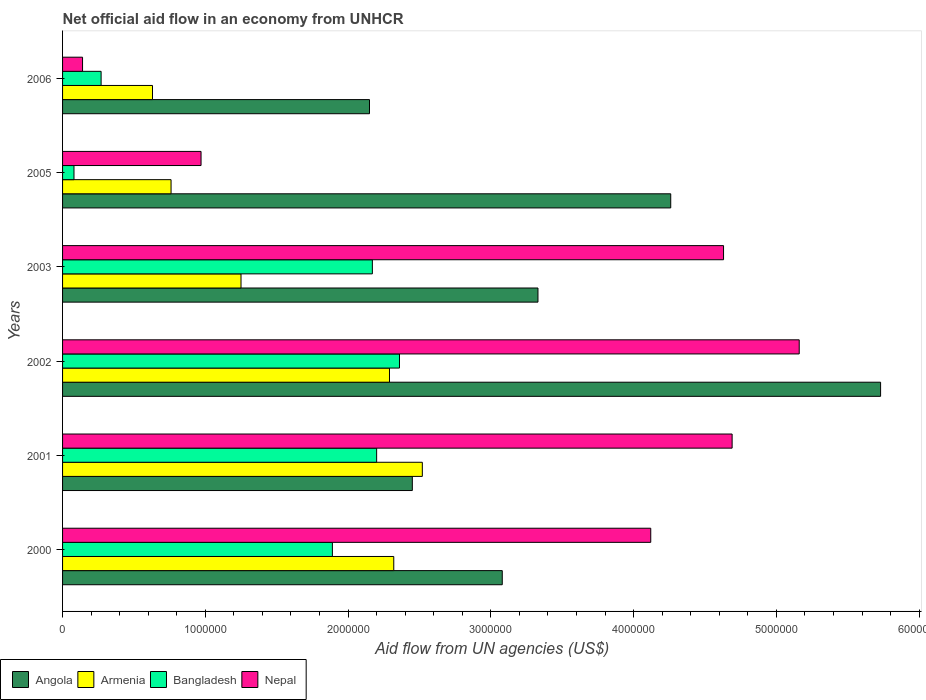How many groups of bars are there?
Give a very brief answer. 6. Are the number of bars per tick equal to the number of legend labels?
Ensure brevity in your answer.  Yes. Are the number of bars on each tick of the Y-axis equal?
Your answer should be very brief. Yes. How many bars are there on the 3rd tick from the top?
Provide a succinct answer. 4. What is the label of the 3rd group of bars from the top?
Your answer should be compact. 2003. What is the net official aid flow in Angola in 2003?
Offer a terse response. 3.33e+06. Across all years, what is the maximum net official aid flow in Nepal?
Your answer should be very brief. 5.16e+06. Across all years, what is the minimum net official aid flow in Nepal?
Your answer should be very brief. 1.40e+05. In which year was the net official aid flow in Bangladesh maximum?
Offer a terse response. 2002. In which year was the net official aid flow in Angola minimum?
Your answer should be compact. 2006. What is the total net official aid flow in Nepal in the graph?
Provide a succinct answer. 1.97e+07. What is the difference between the net official aid flow in Armenia in 2000 and the net official aid flow in Angola in 2002?
Provide a short and direct response. -3.41e+06. What is the average net official aid flow in Armenia per year?
Offer a very short reply. 1.63e+06. In the year 2003, what is the difference between the net official aid flow in Armenia and net official aid flow in Angola?
Provide a succinct answer. -2.08e+06. What is the ratio of the net official aid flow in Armenia in 2000 to that in 2001?
Ensure brevity in your answer.  0.92. Is the net official aid flow in Angola in 2000 less than that in 2006?
Offer a very short reply. No. What is the difference between the highest and the second highest net official aid flow in Bangladesh?
Offer a very short reply. 1.60e+05. What is the difference between the highest and the lowest net official aid flow in Angola?
Ensure brevity in your answer.  3.58e+06. In how many years, is the net official aid flow in Bangladesh greater than the average net official aid flow in Bangladesh taken over all years?
Keep it short and to the point. 4. Is the sum of the net official aid flow in Nepal in 2003 and 2005 greater than the maximum net official aid flow in Angola across all years?
Ensure brevity in your answer.  No. Is it the case that in every year, the sum of the net official aid flow in Bangladesh and net official aid flow in Armenia is greater than the sum of net official aid flow in Angola and net official aid flow in Nepal?
Ensure brevity in your answer.  No. What does the 1st bar from the top in 2005 represents?
Give a very brief answer. Nepal. What does the 1st bar from the bottom in 2005 represents?
Ensure brevity in your answer.  Angola. How many bars are there?
Offer a very short reply. 24. Are all the bars in the graph horizontal?
Provide a short and direct response. Yes. What is the difference between two consecutive major ticks on the X-axis?
Give a very brief answer. 1.00e+06. What is the title of the graph?
Offer a terse response. Net official aid flow in an economy from UNHCR. Does "Jordan" appear as one of the legend labels in the graph?
Ensure brevity in your answer.  No. What is the label or title of the X-axis?
Ensure brevity in your answer.  Aid flow from UN agencies (US$). What is the label or title of the Y-axis?
Offer a very short reply. Years. What is the Aid flow from UN agencies (US$) in Angola in 2000?
Keep it short and to the point. 3.08e+06. What is the Aid flow from UN agencies (US$) in Armenia in 2000?
Provide a short and direct response. 2.32e+06. What is the Aid flow from UN agencies (US$) in Bangladesh in 2000?
Give a very brief answer. 1.89e+06. What is the Aid flow from UN agencies (US$) of Nepal in 2000?
Your response must be concise. 4.12e+06. What is the Aid flow from UN agencies (US$) in Angola in 2001?
Ensure brevity in your answer.  2.45e+06. What is the Aid flow from UN agencies (US$) of Armenia in 2001?
Offer a very short reply. 2.52e+06. What is the Aid flow from UN agencies (US$) in Bangladesh in 2001?
Offer a very short reply. 2.20e+06. What is the Aid flow from UN agencies (US$) in Nepal in 2001?
Your answer should be compact. 4.69e+06. What is the Aid flow from UN agencies (US$) in Angola in 2002?
Make the answer very short. 5.73e+06. What is the Aid flow from UN agencies (US$) of Armenia in 2002?
Ensure brevity in your answer.  2.29e+06. What is the Aid flow from UN agencies (US$) of Bangladesh in 2002?
Your answer should be very brief. 2.36e+06. What is the Aid flow from UN agencies (US$) in Nepal in 2002?
Your answer should be very brief. 5.16e+06. What is the Aid flow from UN agencies (US$) of Angola in 2003?
Make the answer very short. 3.33e+06. What is the Aid flow from UN agencies (US$) of Armenia in 2003?
Make the answer very short. 1.25e+06. What is the Aid flow from UN agencies (US$) of Bangladesh in 2003?
Provide a succinct answer. 2.17e+06. What is the Aid flow from UN agencies (US$) in Nepal in 2003?
Provide a short and direct response. 4.63e+06. What is the Aid flow from UN agencies (US$) of Angola in 2005?
Your answer should be compact. 4.26e+06. What is the Aid flow from UN agencies (US$) of Armenia in 2005?
Your answer should be very brief. 7.60e+05. What is the Aid flow from UN agencies (US$) in Bangladesh in 2005?
Make the answer very short. 8.00e+04. What is the Aid flow from UN agencies (US$) of Nepal in 2005?
Keep it short and to the point. 9.70e+05. What is the Aid flow from UN agencies (US$) in Angola in 2006?
Ensure brevity in your answer.  2.15e+06. What is the Aid flow from UN agencies (US$) in Armenia in 2006?
Offer a terse response. 6.30e+05. What is the Aid flow from UN agencies (US$) in Bangladesh in 2006?
Keep it short and to the point. 2.70e+05. Across all years, what is the maximum Aid flow from UN agencies (US$) in Angola?
Keep it short and to the point. 5.73e+06. Across all years, what is the maximum Aid flow from UN agencies (US$) of Armenia?
Make the answer very short. 2.52e+06. Across all years, what is the maximum Aid flow from UN agencies (US$) in Bangladesh?
Offer a very short reply. 2.36e+06. Across all years, what is the maximum Aid flow from UN agencies (US$) in Nepal?
Your answer should be compact. 5.16e+06. Across all years, what is the minimum Aid flow from UN agencies (US$) in Angola?
Your answer should be compact. 2.15e+06. Across all years, what is the minimum Aid flow from UN agencies (US$) in Armenia?
Offer a very short reply. 6.30e+05. Across all years, what is the minimum Aid flow from UN agencies (US$) in Bangladesh?
Offer a very short reply. 8.00e+04. What is the total Aid flow from UN agencies (US$) in Angola in the graph?
Provide a succinct answer. 2.10e+07. What is the total Aid flow from UN agencies (US$) of Armenia in the graph?
Give a very brief answer. 9.77e+06. What is the total Aid flow from UN agencies (US$) of Bangladesh in the graph?
Offer a very short reply. 8.97e+06. What is the total Aid flow from UN agencies (US$) of Nepal in the graph?
Your answer should be very brief. 1.97e+07. What is the difference between the Aid flow from UN agencies (US$) in Angola in 2000 and that in 2001?
Your answer should be very brief. 6.30e+05. What is the difference between the Aid flow from UN agencies (US$) in Armenia in 2000 and that in 2001?
Provide a succinct answer. -2.00e+05. What is the difference between the Aid flow from UN agencies (US$) of Bangladesh in 2000 and that in 2001?
Your answer should be compact. -3.10e+05. What is the difference between the Aid flow from UN agencies (US$) of Nepal in 2000 and that in 2001?
Provide a succinct answer. -5.70e+05. What is the difference between the Aid flow from UN agencies (US$) in Angola in 2000 and that in 2002?
Offer a very short reply. -2.65e+06. What is the difference between the Aid flow from UN agencies (US$) of Bangladesh in 2000 and that in 2002?
Ensure brevity in your answer.  -4.70e+05. What is the difference between the Aid flow from UN agencies (US$) of Nepal in 2000 and that in 2002?
Provide a short and direct response. -1.04e+06. What is the difference between the Aid flow from UN agencies (US$) in Angola in 2000 and that in 2003?
Offer a terse response. -2.50e+05. What is the difference between the Aid flow from UN agencies (US$) in Armenia in 2000 and that in 2003?
Offer a terse response. 1.07e+06. What is the difference between the Aid flow from UN agencies (US$) of Bangladesh in 2000 and that in 2003?
Make the answer very short. -2.80e+05. What is the difference between the Aid flow from UN agencies (US$) of Nepal in 2000 and that in 2003?
Offer a terse response. -5.10e+05. What is the difference between the Aid flow from UN agencies (US$) in Angola in 2000 and that in 2005?
Give a very brief answer. -1.18e+06. What is the difference between the Aid flow from UN agencies (US$) in Armenia in 2000 and that in 2005?
Your answer should be very brief. 1.56e+06. What is the difference between the Aid flow from UN agencies (US$) of Bangladesh in 2000 and that in 2005?
Keep it short and to the point. 1.81e+06. What is the difference between the Aid flow from UN agencies (US$) of Nepal in 2000 and that in 2005?
Keep it short and to the point. 3.15e+06. What is the difference between the Aid flow from UN agencies (US$) of Angola in 2000 and that in 2006?
Ensure brevity in your answer.  9.30e+05. What is the difference between the Aid flow from UN agencies (US$) in Armenia in 2000 and that in 2006?
Offer a terse response. 1.69e+06. What is the difference between the Aid flow from UN agencies (US$) in Bangladesh in 2000 and that in 2006?
Provide a short and direct response. 1.62e+06. What is the difference between the Aid flow from UN agencies (US$) in Nepal in 2000 and that in 2006?
Offer a very short reply. 3.98e+06. What is the difference between the Aid flow from UN agencies (US$) of Angola in 2001 and that in 2002?
Give a very brief answer. -3.28e+06. What is the difference between the Aid flow from UN agencies (US$) of Armenia in 2001 and that in 2002?
Provide a succinct answer. 2.30e+05. What is the difference between the Aid flow from UN agencies (US$) in Bangladesh in 2001 and that in 2002?
Your response must be concise. -1.60e+05. What is the difference between the Aid flow from UN agencies (US$) of Nepal in 2001 and that in 2002?
Your answer should be very brief. -4.70e+05. What is the difference between the Aid flow from UN agencies (US$) of Angola in 2001 and that in 2003?
Your answer should be very brief. -8.80e+05. What is the difference between the Aid flow from UN agencies (US$) of Armenia in 2001 and that in 2003?
Ensure brevity in your answer.  1.27e+06. What is the difference between the Aid flow from UN agencies (US$) of Bangladesh in 2001 and that in 2003?
Ensure brevity in your answer.  3.00e+04. What is the difference between the Aid flow from UN agencies (US$) in Nepal in 2001 and that in 2003?
Your answer should be very brief. 6.00e+04. What is the difference between the Aid flow from UN agencies (US$) in Angola in 2001 and that in 2005?
Offer a terse response. -1.81e+06. What is the difference between the Aid flow from UN agencies (US$) of Armenia in 2001 and that in 2005?
Your answer should be very brief. 1.76e+06. What is the difference between the Aid flow from UN agencies (US$) of Bangladesh in 2001 and that in 2005?
Ensure brevity in your answer.  2.12e+06. What is the difference between the Aid flow from UN agencies (US$) in Nepal in 2001 and that in 2005?
Your answer should be very brief. 3.72e+06. What is the difference between the Aid flow from UN agencies (US$) in Armenia in 2001 and that in 2006?
Provide a short and direct response. 1.89e+06. What is the difference between the Aid flow from UN agencies (US$) of Bangladesh in 2001 and that in 2006?
Your answer should be compact. 1.93e+06. What is the difference between the Aid flow from UN agencies (US$) in Nepal in 2001 and that in 2006?
Give a very brief answer. 4.55e+06. What is the difference between the Aid flow from UN agencies (US$) of Angola in 2002 and that in 2003?
Provide a succinct answer. 2.40e+06. What is the difference between the Aid flow from UN agencies (US$) of Armenia in 2002 and that in 2003?
Offer a terse response. 1.04e+06. What is the difference between the Aid flow from UN agencies (US$) of Bangladesh in 2002 and that in 2003?
Give a very brief answer. 1.90e+05. What is the difference between the Aid flow from UN agencies (US$) in Nepal in 2002 and that in 2003?
Provide a succinct answer. 5.30e+05. What is the difference between the Aid flow from UN agencies (US$) in Angola in 2002 and that in 2005?
Give a very brief answer. 1.47e+06. What is the difference between the Aid flow from UN agencies (US$) of Armenia in 2002 and that in 2005?
Offer a terse response. 1.53e+06. What is the difference between the Aid flow from UN agencies (US$) of Bangladesh in 2002 and that in 2005?
Provide a short and direct response. 2.28e+06. What is the difference between the Aid flow from UN agencies (US$) in Nepal in 2002 and that in 2005?
Offer a terse response. 4.19e+06. What is the difference between the Aid flow from UN agencies (US$) in Angola in 2002 and that in 2006?
Your answer should be compact. 3.58e+06. What is the difference between the Aid flow from UN agencies (US$) in Armenia in 2002 and that in 2006?
Provide a succinct answer. 1.66e+06. What is the difference between the Aid flow from UN agencies (US$) in Bangladesh in 2002 and that in 2006?
Your answer should be compact. 2.09e+06. What is the difference between the Aid flow from UN agencies (US$) in Nepal in 2002 and that in 2006?
Make the answer very short. 5.02e+06. What is the difference between the Aid flow from UN agencies (US$) of Angola in 2003 and that in 2005?
Ensure brevity in your answer.  -9.30e+05. What is the difference between the Aid flow from UN agencies (US$) of Armenia in 2003 and that in 2005?
Your answer should be very brief. 4.90e+05. What is the difference between the Aid flow from UN agencies (US$) of Bangladesh in 2003 and that in 2005?
Provide a short and direct response. 2.09e+06. What is the difference between the Aid flow from UN agencies (US$) of Nepal in 2003 and that in 2005?
Offer a very short reply. 3.66e+06. What is the difference between the Aid flow from UN agencies (US$) in Angola in 2003 and that in 2006?
Your answer should be compact. 1.18e+06. What is the difference between the Aid flow from UN agencies (US$) of Armenia in 2003 and that in 2006?
Keep it short and to the point. 6.20e+05. What is the difference between the Aid flow from UN agencies (US$) in Bangladesh in 2003 and that in 2006?
Make the answer very short. 1.90e+06. What is the difference between the Aid flow from UN agencies (US$) in Nepal in 2003 and that in 2006?
Make the answer very short. 4.49e+06. What is the difference between the Aid flow from UN agencies (US$) of Angola in 2005 and that in 2006?
Give a very brief answer. 2.11e+06. What is the difference between the Aid flow from UN agencies (US$) in Nepal in 2005 and that in 2006?
Your answer should be compact. 8.30e+05. What is the difference between the Aid flow from UN agencies (US$) in Angola in 2000 and the Aid flow from UN agencies (US$) in Armenia in 2001?
Your response must be concise. 5.60e+05. What is the difference between the Aid flow from UN agencies (US$) of Angola in 2000 and the Aid flow from UN agencies (US$) of Bangladesh in 2001?
Give a very brief answer. 8.80e+05. What is the difference between the Aid flow from UN agencies (US$) in Angola in 2000 and the Aid flow from UN agencies (US$) in Nepal in 2001?
Ensure brevity in your answer.  -1.61e+06. What is the difference between the Aid flow from UN agencies (US$) of Armenia in 2000 and the Aid flow from UN agencies (US$) of Nepal in 2001?
Make the answer very short. -2.37e+06. What is the difference between the Aid flow from UN agencies (US$) of Bangladesh in 2000 and the Aid flow from UN agencies (US$) of Nepal in 2001?
Make the answer very short. -2.80e+06. What is the difference between the Aid flow from UN agencies (US$) of Angola in 2000 and the Aid flow from UN agencies (US$) of Armenia in 2002?
Your answer should be compact. 7.90e+05. What is the difference between the Aid flow from UN agencies (US$) of Angola in 2000 and the Aid flow from UN agencies (US$) of Bangladesh in 2002?
Provide a short and direct response. 7.20e+05. What is the difference between the Aid flow from UN agencies (US$) in Angola in 2000 and the Aid flow from UN agencies (US$) in Nepal in 2002?
Offer a very short reply. -2.08e+06. What is the difference between the Aid flow from UN agencies (US$) of Armenia in 2000 and the Aid flow from UN agencies (US$) of Bangladesh in 2002?
Your answer should be very brief. -4.00e+04. What is the difference between the Aid flow from UN agencies (US$) in Armenia in 2000 and the Aid flow from UN agencies (US$) in Nepal in 2002?
Offer a very short reply. -2.84e+06. What is the difference between the Aid flow from UN agencies (US$) in Bangladesh in 2000 and the Aid flow from UN agencies (US$) in Nepal in 2002?
Keep it short and to the point. -3.27e+06. What is the difference between the Aid flow from UN agencies (US$) in Angola in 2000 and the Aid flow from UN agencies (US$) in Armenia in 2003?
Provide a short and direct response. 1.83e+06. What is the difference between the Aid flow from UN agencies (US$) of Angola in 2000 and the Aid flow from UN agencies (US$) of Bangladesh in 2003?
Offer a very short reply. 9.10e+05. What is the difference between the Aid flow from UN agencies (US$) in Angola in 2000 and the Aid flow from UN agencies (US$) in Nepal in 2003?
Provide a short and direct response. -1.55e+06. What is the difference between the Aid flow from UN agencies (US$) in Armenia in 2000 and the Aid flow from UN agencies (US$) in Nepal in 2003?
Your answer should be compact. -2.31e+06. What is the difference between the Aid flow from UN agencies (US$) in Bangladesh in 2000 and the Aid flow from UN agencies (US$) in Nepal in 2003?
Keep it short and to the point. -2.74e+06. What is the difference between the Aid flow from UN agencies (US$) in Angola in 2000 and the Aid flow from UN agencies (US$) in Armenia in 2005?
Keep it short and to the point. 2.32e+06. What is the difference between the Aid flow from UN agencies (US$) of Angola in 2000 and the Aid flow from UN agencies (US$) of Nepal in 2005?
Offer a very short reply. 2.11e+06. What is the difference between the Aid flow from UN agencies (US$) of Armenia in 2000 and the Aid flow from UN agencies (US$) of Bangladesh in 2005?
Make the answer very short. 2.24e+06. What is the difference between the Aid flow from UN agencies (US$) of Armenia in 2000 and the Aid flow from UN agencies (US$) of Nepal in 2005?
Provide a succinct answer. 1.35e+06. What is the difference between the Aid flow from UN agencies (US$) of Bangladesh in 2000 and the Aid flow from UN agencies (US$) of Nepal in 2005?
Make the answer very short. 9.20e+05. What is the difference between the Aid flow from UN agencies (US$) in Angola in 2000 and the Aid flow from UN agencies (US$) in Armenia in 2006?
Give a very brief answer. 2.45e+06. What is the difference between the Aid flow from UN agencies (US$) in Angola in 2000 and the Aid flow from UN agencies (US$) in Bangladesh in 2006?
Ensure brevity in your answer.  2.81e+06. What is the difference between the Aid flow from UN agencies (US$) in Angola in 2000 and the Aid flow from UN agencies (US$) in Nepal in 2006?
Your answer should be compact. 2.94e+06. What is the difference between the Aid flow from UN agencies (US$) of Armenia in 2000 and the Aid flow from UN agencies (US$) of Bangladesh in 2006?
Ensure brevity in your answer.  2.05e+06. What is the difference between the Aid flow from UN agencies (US$) in Armenia in 2000 and the Aid flow from UN agencies (US$) in Nepal in 2006?
Offer a very short reply. 2.18e+06. What is the difference between the Aid flow from UN agencies (US$) in Bangladesh in 2000 and the Aid flow from UN agencies (US$) in Nepal in 2006?
Your answer should be very brief. 1.75e+06. What is the difference between the Aid flow from UN agencies (US$) in Angola in 2001 and the Aid flow from UN agencies (US$) in Armenia in 2002?
Provide a succinct answer. 1.60e+05. What is the difference between the Aid flow from UN agencies (US$) of Angola in 2001 and the Aid flow from UN agencies (US$) of Nepal in 2002?
Offer a terse response. -2.71e+06. What is the difference between the Aid flow from UN agencies (US$) in Armenia in 2001 and the Aid flow from UN agencies (US$) in Nepal in 2002?
Provide a succinct answer. -2.64e+06. What is the difference between the Aid flow from UN agencies (US$) of Bangladesh in 2001 and the Aid flow from UN agencies (US$) of Nepal in 2002?
Your answer should be very brief. -2.96e+06. What is the difference between the Aid flow from UN agencies (US$) in Angola in 2001 and the Aid flow from UN agencies (US$) in Armenia in 2003?
Keep it short and to the point. 1.20e+06. What is the difference between the Aid flow from UN agencies (US$) in Angola in 2001 and the Aid flow from UN agencies (US$) in Bangladesh in 2003?
Your answer should be compact. 2.80e+05. What is the difference between the Aid flow from UN agencies (US$) of Angola in 2001 and the Aid flow from UN agencies (US$) of Nepal in 2003?
Your answer should be very brief. -2.18e+06. What is the difference between the Aid flow from UN agencies (US$) in Armenia in 2001 and the Aid flow from UN agencies (US$) in Bangladesh in 2003?
Make the answer very short. 3.50e+05. What is the difference between the Aid flow from UN agencies (US$) of Armenia in 2001 and the Aid flow from UN agencies (US$) of Nepal in 2003?
Your response must be concise. -2.11e+06. What is the difference between the Aid flow from UN agencies (US$) in Bangladesh in 2001 and the Aid flow from UN agencies (US$) in Nepal in 2003?
Your answer should be compact. -2.43e+06. What is the difference between the Aid flow from UN agencies (US$) of Angola in 2001 and the Aid flow from UN agencies (US$) of Armenia in 2005?
Provide a short and direct response. 1.69e+06. What is the difference between the Aid flow from UN agencies (US$) of Angola in 2001 and the Aid flow from UN agencies (US$) of Bangladesh in 2005?
Your response must be concise. 2.37e+06. What is the difference between the Aid flow from UN agencies (US$) of Angola in 2001 and the Aid flow from UN agencies (US$) of Nepal in 2005?
Your answer should be very brief. 1.48e+06. What is the difference between the Aid flow from UN agencies (US$) in Armenia in 2001 and the Aid flow from UN agencies (US$) in Bangladesh in 2005?
Give a very brief answer. 2.44e+06. What is the difference between the Aid flow from UN agencies (US$) of Armenia in 2001 and the Aid flow from UN agencies (US$) of Nepal in 2005?
Make the answer very short. 1.55e+06. What is the difference between the Aid flow from UN agencies (US$) in Bangladesh in 2001 and the Aid flow from UN agencies (US$) in Nepal in 2005?
Provide a succinct answer. 1.23e+06. What is the difference between the Aid flow from UN agencies (US$) in Angola in 2001 and the Aid flow from UN agencies (US$) in Armenia in 2006?
Offer a terse response. 1.82e+06. What is the difference between the Aid flow from UN agencies (US$) of Angola in 2001 and the Aid flow from UN agencies (US$) of Bangladesh in 2006?
Offer a terse response. 2.18e+06. What is the difference between the Aid flow from UN agencies (US$) of Angola in 2001 and the Aid flow from UN agencies (US$) of Nepal in 2006?
Offer a terse response. 2.31e+06. What is the difference between the Aid flow from UN agencies (US$) of Armenia in 2001 and the Aid flow from UN agencies (US$) of Bangladesh in 2006?
Your response must be concise. 2.25e+06. What is the difference between the Aid flow from UN agencies (US$) in Armenia in 2001 and the Aid flow from UN agencies (US$) in Nepal in 2006?
Offer a terse response. 2.38e+06. What is the difference between the Aid flow from UN agencies (US$) in Bangladesh in 2001 and the Aid flow from UN agencies (US$) in Nepal in 2006?
Provide a succinct answer. 2.06e+06. What is the difference between the Aid flow from UN agencies (US$) of Angola in 2002 and the Aid flow from UN agencies (US$) of Armenia in 2003?
Your answer should be very brief. 4.48e+06. What is the difference between the Aid flow from UN agencies (US$) in Angola in 2002 and the Aid flow from UN agencies (US$) in Bangladesh in 2003?
Your answer should be compact. 3.56e+06. What is the difference between the Aid flow from UN agencies (US$) in Angola in 2002 and the Aid flow from UN agencies (US$) in Nepal in 2003?
Your answer should be very brief. 1.10e+06. What is the difference between the Aid flow from UN agencies (US$) of Armenia in 2002 and the Aid flow from UN agencies (US$) of Bangladesh in 2003?
Your answer should be very brief. 1.20e+05. What is the difference between the Aid flow from UN agencies (US$) of Armenia in 2002 and the Aid flow from UN agencies (US$) of Nepal in 2003?
Your answer should be very brief. -2.34e+06. What is the difference between the Aid flow from UN agencies (US$) of Bangladesh in 2002 and the Aid flow from UN agencies (US$) of Nepal in 2003?
Ensure brevity in your answer.  -2.27e+06. What is the difference between the Aid flow from UN agencies (US$) in Angola in 2002 and the Aid flow from UN agencies (US$) in Armenia in 2005?
Provide a succinct answer. 4.97e+06. What is the difference between the Aid flow from UN agencies (US$) in Angola in 2002 and the Aid flow from UN agencies (US$) in Bangladesh in 2005?
Your answer should be compact. 5.65e+06. What is the difference between the Aid flow from UN agencies (US$) in Angola in 2002 and the Aid flow from UN agencies (US$) in Nepal in 2005?
Your response must be concise. 4.76e+06. What is the difference between the Aid flow from UN agencies (US$) of Armenia in 2002 and the Aid flow from UN agencies (US$) of Bangladesh in 2005?
Your answer should be compact. 2.21e+06. What is the difference between the Aid flow from UN agencies (US$) of Armenia in 2002 and the Aid flow from UN agencies (US$) of Nepal in 2005?
Offer a terse response. 1.32e+06. What is the difference between the Aid flow from UN agencies (US$) of Bangladesh in 2002 and the Aid flow from UN agencies (US$) of Nepal in 2005?
Make the answer very short. 1.39e+06. What is the difference between the Aid flow from UN agencies (US$) of Angola in 2002 and the Aid flow from UN agencies (US$) of Armenia in 2006?
Offer a very short reply. 5.10e+06. What is the difference between the Aid flow from UN agencies (US$) of Angola in 2002 and the Aid flow from UN agencies (US$) of Bangladesh in 2006?
Offer a very short reply. 5.46e+06. What is the difference between the Aid flow from UN agencies (US$) in Angola in 2002 and the Aid flow from UN agencies (US$) in Nepal in 2006?
Give a very brief answer. 5.59e+06. What is the difference between the Aid flow from UN agencies (US$) of Armenia in 2002 and the Aid flow from UN agencies (US$) of Bangladesh in 2006?
Offer a very short reply. 2.02e+06. What is the difference between the Aid flow from UN agencies (US$) in Armenia in 2002 and the Aid flow from UN agencies (US$) in Nepal in 2006?
Your response must be concise. 2.15e+06. What is the difference between the Aid flow from UN agencies (US$) of Bangladesh in 2002 and the Aid flow from UN agencies (US$) of Nepal in 2006?
Your answer should be compact. 2.22e+06. What is the difference between the Aid flow from UN agencies (US$) of Angola in 2003 and the Aid flow from UN agencies (US$) of Armenia in 2005?
Offer a very short reply. 2.57e+06. What is the difference between the Aid flow from UN agencies (US$) in Angola in 2003 and the Aid flow from UN agencies (US$) in Bangladesh in 2005?
Give a very brief answer. 3.25e+06. What is the difference between the Aid flow from UN agencies (US$) of Angola in 2003 and the Aid flow from UN agencies (US$) of Nepal in 2005?
Provide a succinct answer. 2.36e+06. What is the difference between the Aid flow from UN agencies (US$) of Armenia in 2003 and the Aid flow from UN agencies (US$) of Bangladesh in 2005?
Your response must be concise. 1.17e+06. What is the difference between the Aid flow from UN agencies (US$) in Armenia in 2003 and the Aid flow from UN agencies (US$) in Nepal in 2005?
Provide a succinct answer. 2.80e+05. What is the difference between the Aid flow from UN agencies (US$) in Bangladesh in 2003 and the Aid flow from UN agencies (US$) in Nepal in 2005?
Provide a succinct answer. 1.20e+06. What is the difference between the Aid flow from UN agencies (US$) in Angola in 2003 and the Aid flow from UN agencies (US$) in Armenia in 2006?
Keep it short and to the point. 2.70e+06. What is the difference between the Aid flow from UN agencies (US$) of Angola in 2003 and the Aid flow from UN agencies (US$) of Bangladesh in 2006?
Your response must be concise. 3.06e+06. What is the difference between the Aid flow from UN agencies (US$) of Angola in 2003 and the Aid flow from UN agencies (US$) of Nepal in 2006?
Offer a terse response. 3.19e+06. What is the difference between the Aid flow from UN agencies (US$) in Armenia in 2003 and the Aid flow from UN agencies (US$) in Bangladesh in 2006?
Your answer should be compact. 9.80e+05. What is the difference between the Aid flow from UN agencies (US$) in Armenia in 2003 and the Aid flow from UN agencies (US$) in Nepal in 2006?
Offer a very short reply. 1.11e+06. What is the difference between the Aid flow from UN agencies (US$) of Bangladesh in 2003 and the Aid flow from UN agencies (US$) of Nepal in 2006?
Your response must be concise. 2.03e+06. What is the difference between the Aid flow from UN agencies (US$) of Angola in 2005 and the Aid flow from UN agencies (US$) of Armenia in 2006?
Give a very brief answer. 3.63e+06. What is the difference between the Aid flow from UN agencies (US$) in Angola in 2005 and the Aid flow from UN agencies (US$) in Bangladesh in 2006?
Make the answer very short. 3.99e+06. What is the difference between the Aid flow from UN agencies (US$) in Angola in 2005 and the Aid flow from UN agencies (US$) in Nepal in 2006?
Make the answer very short. 4.12e+06. What is the difference between the Aid flow from UN agencies (US$) in Armenia in 2005 and the Aid flow from UN agencies (US$) in Nepal in 2006?
Ensure brevity in your answer.  6.20e+05. What is the difference between the Aid flow from UN agencies (US$) of Bangladesh in 2005 and the Aid flow from UN agencies (US$) of Nepal in 2006?
Keep it short and to the point. -6.00e+04. What is the average Aid flow from UN agencies (US$) in Angola per year?
Provide a succinct answer. 3.50e+06. What is the average Aid flow from UN agencies (US$) of Armenia per year?
Provide a short and direct response. 1.63e+06. What is the average Aid flow from UN agencies (US$) of Bangladesh per year?
Make the answer very short. 1.50e+06. What is the average Aid flow from UN agencies (US$) of Nepal per year?
Provide a short and direct response. 3.28e+06. In the year 2000, what is the difference between the Aid flow from UN agencies (US$) of Angola and Aid flow from UN agencies (US$) of Armenia?
Your response must be concise. 7.60e+05. In the year 2000, what is the difference between the Aid flow from UN agencies (US$) of Angola and Aid flow from UN agencies (US$) of Bangladesh?
Offer a terse response. 1.19e+06. In the year 2000, what is the difference between the Aid flow from UN agencies (US$) in Angola and Aid flow from UN agencies (US$) in Nepal?
Offer a very short reply. -1.04e+06. In the year 2000, what is the difference between the Aid flow from UN agencies (US$) of Armenia and Aid flow from UN agencies (US$) of Nepal?
Make the answer very short. -1.80e+06. In the year 2000, what is the difference between the Aid flow from UN agencies (US$) of Bangladesh and Aid flow from UN agencies (US$) of Nepal?
Keep it short and to the point. -2.23e+06. In the year 2001, what is the difference between the Aid flow from UN agencies (US$) in Angola and Aid flow from UN agencies (US$) in Armenia?
Your response must be concise. -7.00e+04. In the year 2001, what is the difference between the Aid flow from UN agencies (US$) of Angola and Aid flow from UN agencies (US$) of Bangladesh?
Your answer should be very brief. 2.50e+05. In the year 2001, what is the difference between the Aid flow from UN agencies (US$) in Angola and Aid flow from UN agencies (US$) in Nepal?
Provide a succinct answer. -2.24e+06. In the year 2001, what is the difference between the Aid flow from UN agencies (US$) in Armenia and Aid flow from UN agencies (US$) in Bangladesh?
Offer a very short reply. 3.20e+05. In the year 2001, what is the difference between the Aid flow from UN agencies (US$) in Armenia and Aid flow from UN agencies (US$) in Nepal?
Your response must be concise. -2.17e+06. In the year 2001, what is the difference between the Aid flow from UN agencies (US$) in Bangladesh and Aid flow from UN agencies (US$) in Nepal?
Your answer should be compact. -2.49e+06. In the year 2002, what is the difference between the Aid flow from UN agencies (US$) in Angola and Aid flow from UN agencies (US$) in Armenia?
Your answer should be compact. 3.44e+06. In the year 2002, what is the difference between the Aid flow from UN agencies (US$) of Angola and Aid flow from UN agencies (US$) of Bangladesh?
Make the answer very short. 3.37e+06. In the year 2002, what is the difference between the Aid flow from UN agencies (US$) in Angola and Aid flow from UN agencies (US$) in Nepal?
Provide a short and direct response. 5.70e+05. In the year 2002, what is the difference between the Aid flow from UN agencies (US$) of Armenia and Aid flow from UN agencies (US$) of Bangladesh?
Make the answer very short. -7.00e+04. In the year 2002, what is the difference between the Aid flow from UN agencies (US$) in Armenia and Aid flow from UN agencies (US$) in Nepal?
Make the answer very short. -2.87e+06. In the year 2002, what is the difference between the Aid flow from UN agencies (US$) of Bangladesh and Aid flow from UN agencies (US$) of Nepal?
Ensure brevity in your answer.  -2.80e+06. In the year 2003, what is the difference between the Aid flow from UN agencies (US$) of Angola and Aid flow from UN agencies (US$) of Armenia?
Your response must be concise. 2.08e+06. In the year 2003, what is the difference between the Aid flow from UN agencies (US$) in Angola and Aid flow from UN agencies (US$) in Bangladesh?
Keep it short and to the point. 1.16e+06. In the year 2003, what is the difference between the Aid flow from UN agencies (US$) of Angola and Aid flow from UN agencies (US$) of Nepal?
Offer a very short reply. -1.30e+06. In the year 2003, what is the difference between the Aid flow from UN agencies (US$) in Armenia and Aid flow from UN agencies (US$) in Bangladesh?
Offer a very short reply. -9.20e+05. In the year 2003, what is the difference between the Aid flow from UN agencies (US$) in Armenia and Aid flow from UN agencies (US$) in Nepal?
Offer a very short reply. -3.38e+06. In the year 2003, what is the difference between the Aid flow from UN agencies (US$) in Bangladesh and Aid flow from UN agencies (US$) in Nepal?
Ensure brevity in your answer.  -2.46e+06. In the year 2005, what is the difference between the Aid flow from UN agencies (US$) of Angola and Aid flow from UN agencies (US$) of Armenia?
Offer a terse response. 3.50e+06. In the year 2005, what is the difference between the Aid flow from UN agencies (US$) in Angola and Aid flow from UN agencies (US$) in Bangladesh?
Keep it short and to the point. 4.18e+06. In the year 2005, what is the difference between the Aid flow from UN agencies (US$) in Angola and Aid flow from UN agencies (US$) in Nepal?
Your response must be concise. 3.29e+06. In the year 2005, what is the difference between the Aid flow from UN agencies (US$) of Armenia and Aid flow from UN agencies (US$) of Bangladesh?
Keep it short and to the point. 6.80e+05. In the year 2005, what is the difference between the Aid flow from UN agencies (US$) in Bangladesh and Aid flow from UN agencies (US$) in Nepal?
Your answer should be very brief. -8.90e+05. In the year 2006, what is the difference between the Aid flow from UN agencies (US$) of Angola and Aid flow from UN agencies (US$) of Armenia?
Give a very brief answer. 1.52e+06. In the year 2006, what is the difference between the Aid flow from UN agencies (US$) of Angola and Aid flow from UN agencies (US$) of Bangladesh?
Your answer should be compact. 1.88e+06. In the year 2006, what is the difference between the Aid flow from UN agencies (US$) of Angola and Aid flow from UN agencies (US$) of Nepal?
Your response must be concise. 2.01e+06. In the year 2006, what is the difference between the Aid flow from UN agencies (US$) of Armenia and Aid flow from UN agencies (US$) of Bangladesh?
Provide a short and direct response. 3.60e+05. What is the ratio of the Aid flow from UN agencies (US$) of Angola in 2000 to that in 2001?
Give a very brief answer. 1.26. What is the ratio of the Aid flow from UN agencies (US$) of Armenia in 2000 to that in 2001?
Your response must be concise. 0.92. What is the ratio of the Aid flow from UN agencies (US$) in Bangladesh in 2000 to that in 2001?
Offer a terse response. 0.86. What is the ratio of the Aid flow from UN agencies (US$) in Nepal in 2000 to that in 2001?
Your answer should be compact. 0.88. What is the ratio of the Aid flow from UN agencies (US$) in Angola in 2000 to that in 2002?
Your answer should be compact. 0.54. What is the ratio of the Aid flow from UN agencies (US$) of Armenia in 2000 to that in 2002?
Provide a short and direct response. 1.01. What is the ratio of the Aid flow from UN agencies (US$) of Bangladesh in 2000 to that in 2002?
Give a very brief answer. 0.8. What is the ratio of the Aid flow from UN agencies (US$) of Nepal in 2000 to that in 2002?
Offer a very short reply. 0.8. What is the ratio of the Aid flow from UN agencies (US$) of Angola in 2000 to that in 2003?
Offer a very short reply. 0.92. What is the ratio of the Aid flow from UN agencies (US$) in Armenia in 2000 to that in 2003?
Keep it short and to the point. 1.86. What is the ratio of the Aid flow from UN agencies (US$) in Bangladesh in 2000 to that in 2003?
Keep it short and to the point. 0.87. What is the ratio of the Aid flow from UN agencies (US$) of Nepal in 2000 to that in 2003?
Ensure brevity in your answer.  0.89. What is the ratio of the Aid flow from UN agencies (US$) in Angola in 2000 to that in 2005?
Offer a very short reply. 0.72. What is the ratio of the Aid flow from UN agencies (US$) in Armenia in 2000 to that in 2005?
Offer a very short reply. 3.05. What is the ratio of the Aid flow from UN agencies (US$) of Bangladesh in 2000 to that in 2005?
Offer a terse response. 23.62. What is the ratio of the Aid flow from UN agencies (US$) in Nepal in 2000 to that in 2005?
Make the answer very short. 4.25. What is the ratio of the Aid flow from UN agencies (US$) in Angola in 2000 to that in 2006?
Offer a terse response. 1.43. What is the ratio of the Aid flow from UN agencies (US$) of Armenia in 2000 to that in 2006?
Keep it short and to the point. 3.68. What is the ratio of the Aid flow from UN agencies (US$) in Bangladesh in 2000 to that in 2006?
Make the answer very short. 7. What is the ratio of the Aid flow from UN agencies (US$) in Nepal in 2000 to that in 2006?
Keep it short and to the point. 29.43. What is the ratio of the Aid flow from UN agencies (US$) in Angola in 2001 to that in 2002?
Offer a terse response. 0.43. What is the ratio of the Aid flow from UN agencies (US$) of Armenia in 2001 to that in 2002?
Offer a very short reply. 1.1. What is the ratio of the Aid flow from UN agencies (US$) in Bangladesh in 2001 to that in 2002?
Keep it short and to the point. 0.93. What is the ratio of the Aid flow from UN agencies (US$) of Nepal in 2001 to that in 2002?
Offer a very short reply. 0.91. What is the ratio of the Aid flow from UN agencies (US$) of Angola in 2001 to that in 2003?
Your response must be concise. 0.74. What is the ratio of the Aid flow from UN agencies (US$) of Armenia in 2001 to that in 2003?
Offer a terse response. 2.02. What is the ratio of the Aid flow from UN agencies (US$) in Bangladesh in 2001 to that in 2003?
Make the answer very short. 1.01. What is the ratio of the Aid flow from UN agencies (US$) in Nepal in 2001 to that in 2003?
Keep it short and to the point. 1.01. What is the ratio of the Aid flow from UN agencies (US$) in Angola in 2001 to that in 2005?
Your answer should be compact. 0.58. What is the ratio of the Aid flow from UN agencies (US$) in Armenia in 2001 to that in 2005?
Make the answer very short. 3.32. What is the ratio of the Aid flow from UN agencies (US$) of Nepal in 2001 to that in 2005?
Make the answer very short. 4.84. What is the ratio of the Aid flow from UN agencies (US$) in Angola in 2001 to that in 2006?
Make the answer very short. 1.14. What is the ratio of the Aid flow from UN agencies (US$) in Armenia in 2001 to that in 2006?
Keep it short and to the point. 4. What is the ratio of the Aid flow from UN agencies (US$) of Bangladesh in 2001 to that in 2006?
Your answer should be very brief. 8.15. What is the ratio of the Aid flow from UN agencies (US$) in Nepal in 2001 to that in 2006?
Keep it short and to the point. 33.5. What is the ratio of the Aid flow from UN agencies (US$) in Angola in 2002 to that in 2003?
Ensure brevity in your answer.  1.72. What is the ratio of the Aid flow from UN agencies (US$) in Armenia in 2002 to that in 2003?
Offer a terse response. 1.83. What is the ratio of the Aid flow from UN agencies (US$) of Bangladesh in 2002 to that in 2003?
Your answer should be compact. 1.09. What is the ratio of the Aid flow from UN agencies (US$) in Nepal in 2002 to that in 2003?
Your response must be concise. 1.11. What is the ratio of the Aid flow from UN agencies (US$) of Angola in 2002 to that in 2005?
Keep it short and to the point. 1.35. What is the ratio of the Aid flow from UN agencies (US$) in Armenia in 2002 to that in 2005?
Make the answer very short. 3.01. What is the ratio of the Aid flow from UN agencies (US$) of Bangladesh in 2002 to that in 2005?
Your answer should be compact. 29.5. What is the ratio of the Aid flow from UN agencies (US$) of Nepal in 2002 to that in 2005?
Give a very brief answer. 5.32. What is the ratio of the Aid flow from UN agencies (US$) of Angola in 2002 to that in 2006?
Provide a short and direct response. 2.67. What is the ratio of the Aid flow from UN agencies (US$) of Armenia in 2002 to that in 2006?
Offer a very short reply. 3.63. What is the ratio of the Aid flow from UN agencies (US$) of Bangladesh in 2002 to that in 2006?
Offer a very short reply. 8.74. What is the ratio of the Aid flow from UN agencies (US$) in Nepal in 2002 to that in 2006?
Offer a very short reply. 36.86. What is the ratio of the Aid flow from UN agencies (US$) in Angola in 2003 to that in 2005?
Your answer should be very brief. 0.78. What is the ratio of the Aid flow from UN agencies (US$) of Armenia in 2003 to that in 2005?
Make the answer very short. 1.64. What is the ratio of the Aid flow from UN agencies (US$) of Bangladesh in 2003 to that in 2005?
Offer a terse response. 27.12. What is the ratio of the Aid flow from UN agencies (US$) of Nepal in 2003 to that in 2005?
Your answer should be very brief. 4.77. What is the ratio of the Aid flow from UN agencies (US$) of Angola in 2003 to that in 2006?
Give a very brief answer. 1.55. What is the ratio of the Aid flow from UN agencies (US$) of Armenia in 2003 to that in 2006?
Make the answer very short. 1.98. What is the ratio of the Aid flow from UN agencies (US$) in Bangladesh in 2003 to that in 2006?
Keep it short and to the point. 8.04. What is the ratio of the Aid flow from UN agencies (US$) of Nepal in 2003 to that in 2006?
Make the answer very short. 33.07. What is the ratio of the Aid flow from UN agencies (US$) of Angola in 2005 to that in 2006?
Your response must be concise. 1.98. What is the ratio of the Aid flow from UN agencies (US$) of Armenia in 2005 to that in 2006?
Offer a terse response. 1.21. What is the ratio of the Aid flow from UN agencies (US$) in Bangladesh in 2005 to that in 2006?
Your response must be concise. 0.3. What is the ratio of the Aid flow from UN agencies (US$) in Nepal in 2005 to that in 2006?
Provide a short and direct response. 6.93. What is the difference between the highest and the second highest Aid flow from UN agencies (US$) in Angola?
Keep it short and to the point. 1.47e+06. What is the difference between the highest and the second highest Aid flow from UN agencies (US$) of Bangladesh?
Your answer should be compact. 1.60e+05. What is the difference between the highest and the second highest Aid flow from UN agencies (US$) of Nepal?
Provide a short and direct response. 4.70e+05. What is the difference between the highest and the lowest Aid flow from UN agencies (US$) of Angola?
Offer a very short reply. 3.58e+06. What is the difference between the highest and the lowest Aid flow from UN agencies (US$) in Armenia?
Keep it short and to the point. 1.89e+06. What is the difference between the highest and the lowest Aid flow from UN agencies (US$) of Bangladesh?
Provide a succinct answer. 2.28e+06. What is the difference between the highest and the lowest Aid flow from UN agencies (US$) of Nepal?
Make the answer very short. 5.02e+06. 